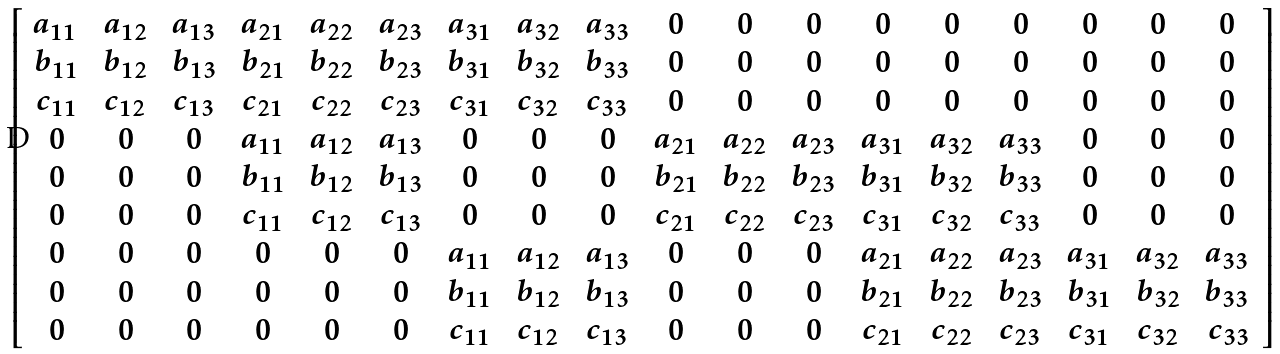<formula> <loc_0><loc_0><loc_500><loc_500>\, \left [ \begin{array} { c c c c c c c c c c c c c c c c c c } a _ { 1 1 } \, & \, a _ { 1 2 } \, & \, a _ { 1 3 } \, & \, a _ { 2 1 } \, & \, a _ { 2 2 } \, & \, a _ { 2 3 } \, & \, a _ { 3 1 } \, & \, a _ { 3 2 } \, & \, a _ { 3 3 } \, & \, 0 \, & \, 0 \, & \, 0 \, & \, 0 \, & \, 0 \, & \, 0 \, & \, 0 \, & \, 0 \, & \, 0 \, \\ \, b _ { 1 1 } \, & \, b _ { 1 2 } \, & \, b _ { 1 3 } \, & \, b _ { 2 1 } \, & \, b _ { 2 2 } \, & \, b _ { 2 3 } \, & \, b _ { 3 1 } \, & \, b _ { 3 2 } \, & \, b _ { 3 3 } \, & \, 0 \, & \, 0 \, & \, 0 \, & \, 0 \, & \, 0 \, & \, 0 \, & \, 0 \, & \, 0 \, & \, 0 \, \\ \, c _ { 1 1 } \, & \, c _ { 1 2 } \, & \, c _ { 1 3 } \, & \, c _ { 2 1 } \, & \, c _ { 2 2 } \, & \, c _ { 2 3 } \, & \, c _ { 3 1 } \, & \, c _ { 3 2 } \, & \, c _ { 3 3 } \, & \, 0 \, & \, 0 \, & \, 0 \, & \, 0 \, & \, 0 \, & \, 0 \, & \, 0 \, & \, 0 \, & \, 0 \, \\ \, 0 \, & \, 0 \, & \, 0 \, & \, a _ { 1 1 } \, & \, a _ { 1 2 } \, & \, a _ { 1 3 } \, & \, 0 \, & \, 0 \, & \, 0 \, & \, a _ { 2 1 } \, & \, a _ { 2 2 } \, & \, a _ { 2 3 } \, & \, a _ { 3 1 } \, & \, a _ { 3 2 } \, & \, a _ { 3 3 } \, & \, 0 \, & \, 0 \, & \, 0 \, \\ \, 0 \, & \, 0 \, & \, 0 \, & \, b _ { 1 1 } \, & \, b _ { 1 2 } \, & \, b _ { 1 3 } \, & \, 0 \, & \, 0 \, & \, 0 \, & \, b _ { 2 1 } \, & \, b _ { 2 2 } \, & \, b _ { 2 3 } \, & \, b _ { 3 1 } \, & \, b _ { 3 2 } \, & \, b _ { 3 3 } \, & \, 0 \, & \, 0 \, & \, 0 \, \\ \, 0 \, & \, 0 \, & \, 0 \, & \, c _ { 1 1 } \, & \, c _ { 1 2 } \, & \, c _ { 1 3 } \, & \, 0 \, & \, 0 \, & \, 0 \, & \, c _ { 2 1 } \, & \, c _ { 2 2 } \, & \, c _ { 2 3 } \, & \, c _ { 3 1 } \, & \, c _ { 3 2 } \, & \, c _ { 3 3 } \, & \, 0 \, & \, 0 \, & \, 0 \, \\ \, 0 \, & \, 0 \, & \, 0 \, & \, 0 \, & \, 0 \, & \, 0 \, & \, a _ { 1 1 } \, & \, a _ { 1 2 } \, & \, a _ { 1 3 } \, & \, 0 \, & \, 0 \, & \, 0 \, & \, a _ { 2 1 } \, & \, a _ { 2 2 } \, & \, a _ { 2 3 } \, & \, a _ { 3 1 } \, & \, a _ { 3 2 } \, & \, a _ { 3 3 } \, \\ \, 0 \, & \, 0 \, & \, 0 \, & \, 0 \, & \, 0 \, & \, 0 \, & \, b _ { 1 1 } \, & \, b _ { 1 2 } \, & \, b _ { 1 3 } \, & \, 0 \, & \, 0 \, & \, 0 \, & \, b _ { 2 1 } \, & \, b _ { 2 2 } \, & \, b _ { 2 3 } \, & \, b _ { 3 1 } \, & \, b _ { 3 2 } \, & \, b _ { 3 3 } \, \\ \, 0 \, & \, 0 \, & \, 0 \, & \, 0 \, & \, 0 \, & \, 0 \, & \, c _ { 1 1 } \, & \, c _ { 1 2 } \, & \, c _ { 1 3 } \, & \, 0 \, & \, 0 \, & \, 0 \, & \, c _ { 2 1 } \, & \, c _ { 2 2 } \, & \, c _ { 2 3 } \, & \, c _ { 3 1 } \, & \, c _ { 3 2 } \, & \, c _ { 3 3 } \end{array} \right ]</formula> 